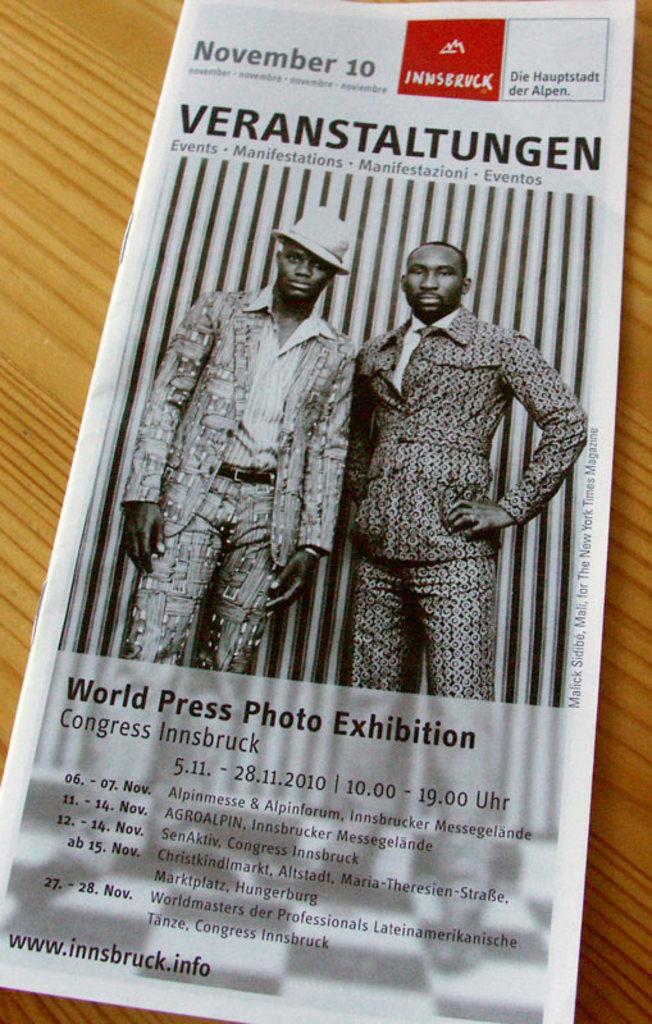Could you give a brief overview of what you see in this image? In this image, I can see a brochure on a table. This picture might be taken in a room. 